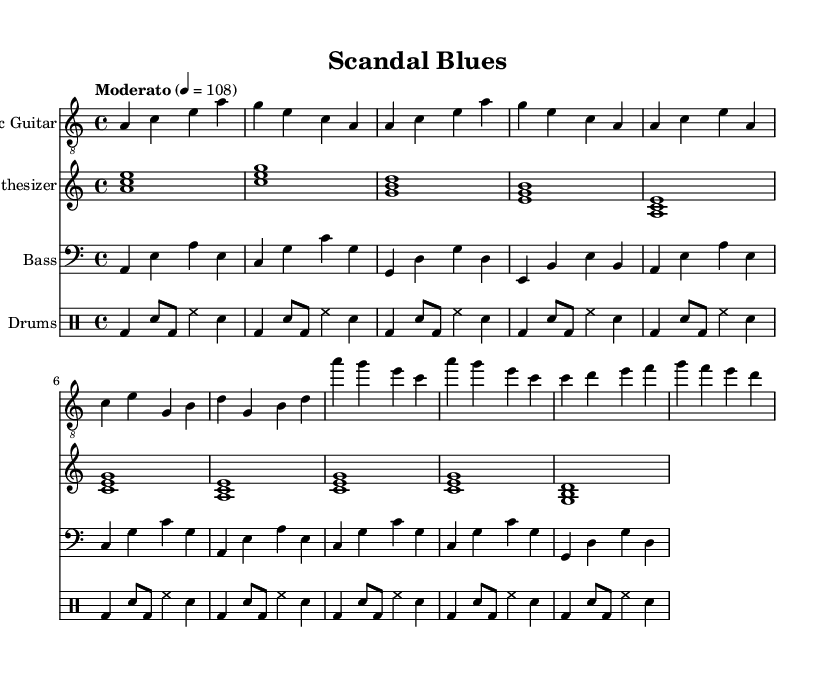What is the key signature of this music? The key signature is A minor, indicated by no sharps or flats. It is determined by checking the key signature at the beginning of the piece, which shows A minor has no accidentals.
Answer: A minor What is the time signature of the music? The time signature is 4/4, commonly found at the beginning of the sheet music. This is identified by the fraction-like symbol that indicates it consists of four beats per measure.
Answer: 4/4 What is the tempo marking for this piece? The tempo is indicated as "Moderato" at a speed of 108 beats per minute. This information is presented in the tempo marking at the beginning, defining the pace of the music.
Answer: Moderato 108 How many unique sections does the piece have? The piece has three unique sections: Intro, Verse 1, and Chorus as well as a Bridge section. This can be inferred from the structure of the music, where different musical phrases represent distinct parts.
Answer: Four What instrument plays the arpeggiated chords? The synthesizer plays the arpeggiated chords, as indicated by the staff labeled "Synthesizer" for the synthArp part. This is observed in the notation that shows the distinct synthesizer line contrasting with the guitar and bass.
Answer: Synthesizer What rhythmic pattern is used in the drums part? The drums part mostly features a pattern alternating between bass drum hits and snare hits, as indicated in the drummode notation representing typical rock and blues styles. The repeated pattern reflects the fusion style aimed at creating a strong rhythmic foundation.
Answer: Bass and snare What characterizes the fusion style of this music? The fusion style is characterized by the combination of blues elements with electronic instrumentation. This can be deduced from the electric guitar's bluesy melodies combined with the synthetic textures of the synthesizer, creating a unique blend of genres.
Answer: Blues-electronic fusion 